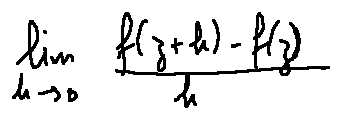<formula> <loc_0><loc_0><loc_500><loc_500>\lim \lim i t s _ { h \rightarrow 0 } \frac { f ( z + h ) - f ( z ) } { h }</formula> 